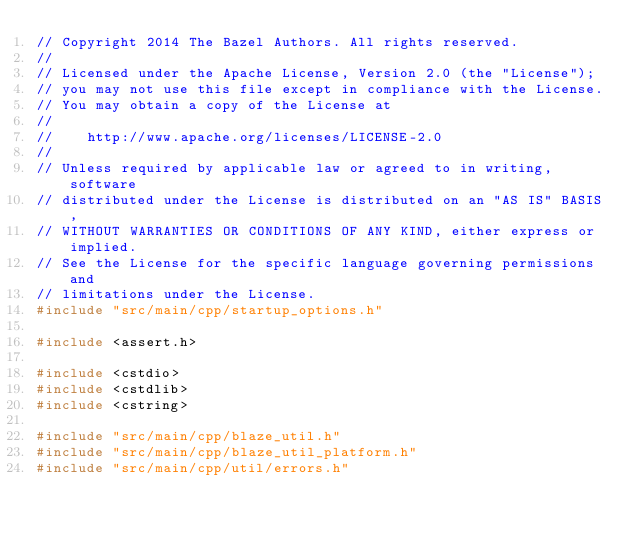Convert code to text. <code><loc_0><loc_0><loc_500><loc_500><_C++_>// Copyright 2014 The Bazel Authors. All rights reserved.
//
// Licensed under the Apache License, Version 2.0 (the "License");
// you may not use this file except in compliance with the License.
// You may obtain a copy of the License at
//
//    http://www.apache.org/licenses/LICENSE-2.0
//
// Unless required by applicable law or agreed to in writing, software
// distributed under the License is distributed on an "AS IS" BASIS,
// WITHOUT WARRANTIES OR CONDITIONS OF ANY KIND, either express or implied.
// See the License for the specific language governing permissions and
// limitations under the License.
#include "src/main/cpp/startup_options.h"

#include <assert.h>

#include <cstdio>
#include <cstdlib>
#include <cstring>

#include "src/main/cpp/blaze_util.h"
#include "src/main/cpp/blaze_util_platform.h"
#include "src/main/cpp/util/errors.h"</code> 